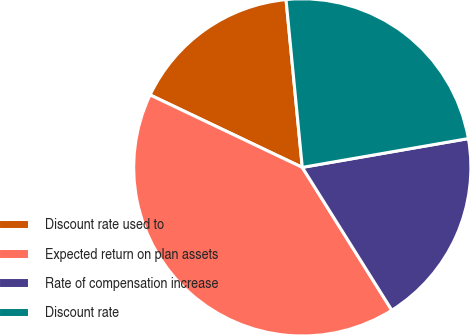<chart> <loc_0><loc_0><loc_500><loc_500><pie_chart><fcel>Discount rate used to<fcel>Expected return on plan assets<fcel>Rate of compensation increase<fcel>Discount rate<nl><fcel>16.39%<fcel>40.98%<fcel>18.82%<fcel>23.8%<nl></chart> 